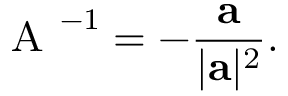Convert formula to latex. <formula><loc_0><loc_0><loc_500><loc_500>{ A } ^ { - 1 } = - \frac { a } { | a | ^ { 2 } } .</formula> 